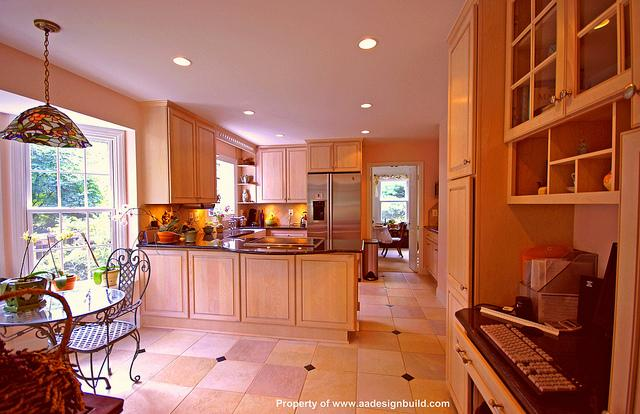What style of lamp is the one above the table? Please explain your reasoning. tiffany style. That lamp has colors. 